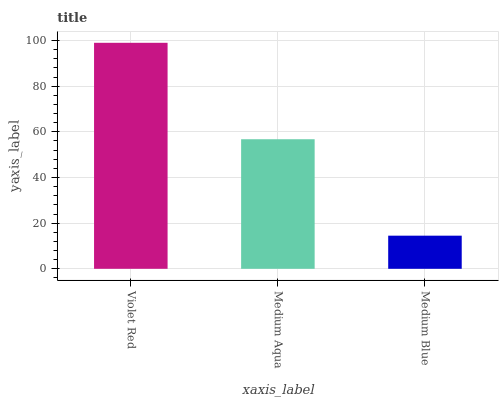Is Medium Blue the minimum?
Answer yes or no. Yes. Is Violet Red the maximum?
Answer yes or no. Yes. Is Medium Aqua the minimum?
Answer yes or no. No. Is Medium Aqua the maximum?
Answer yes or no. No. Is Violet Red greater than Medium Aqua?
Answer yes or no. Yes. Is Medium Aqua less than Violet Red?
Answer yes or no. Yes. Is Medium Aqua greater than Violet Red?
Answer yes or no. No. Is Violet Red less than Medium Aqua?
Answer yes or no. No. Is Medium Aqua the high median?
Answer yes or no. Yes. Is Medium Aqua the low median?
Answer yes or no. Yes. Is Violet Red the high median?
Answer yes or no. No. Is Violet Red the low median?
Answer yes or no. No. 